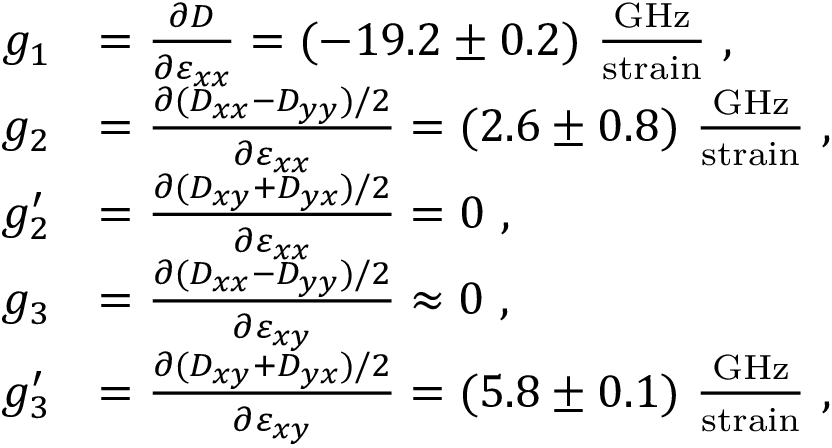Convert formula to latex. <formula><loc_0><loc_0><loc_500><loc_500>\begin{array} { r l } { g _ { 1 } } & { = \frac { \partial D } { \partial \varepsilon _ { x x } } = ( - 1 9 . 2 \pm 0 . 2 ) \frac { G H z } { s t r a i n } \ , } \\ { g _ { 2 } } & { = \frac { \partial ( D _ { x x } - D _ { y y } ) / 2 } { \partial \varepsilon _ { x x } } = ( 2 . 6 \pm 0 . 8 ) \frac { G H z } { s t r a i n } \ , } \\ { g _ { 2 } ^ { \prime } } & { = \frac { \partial ( D _ { x y } + D _ { y x } ) / 2 } { \partial \varepsilon _ { x x } } = 0 \ , } \\ { g _ { 3 } } & { = \frac { \partial ( D _ { x x } - D _ { y y } ) / 2 } { \partial \varepsilon _ { x y } } \approx 0 \ , } \\ { g _ { 3 } ^ { \prime } } & { = \frac { \partial ( D _ { x y } + D _ { y x } ) / 2 } { \partial \varepsilon _ { x y } } = ( 5 . 8 \pm 0 . 1 ) \frac { G H z } { s t r a i n } \ , } \end{array}</formula> 